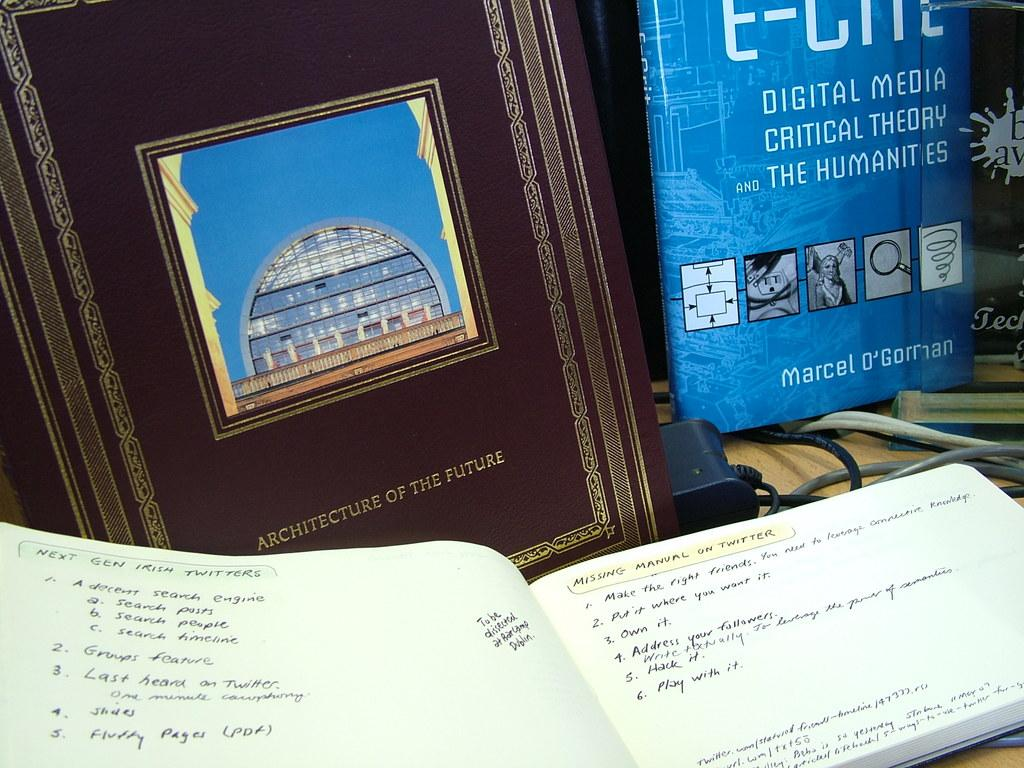What type of items can be seen in the image? There are books and cables in the image. Where are these items located? They are on a wooden platform in the image. How many bears can be seen eating apples on the wooden platform in the image? There are no bears or apples present in the image; it only features books and cables on a wooden platform. 